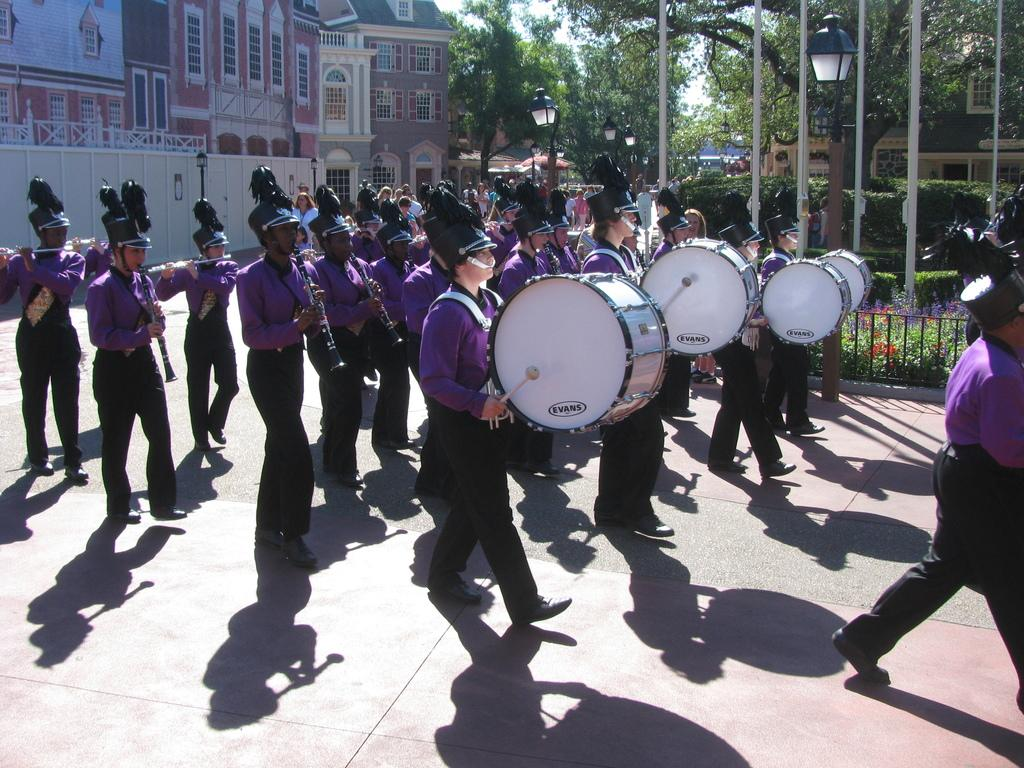What are the people in the image doing? The people in the image are holding musical instruments. What is the setting of the image? The people are walking on a road, and there are buildings and trees visible in the image. What type of crown is the representative wearing in the image? There is no representative or crown present in the image. The people in the image are holding musical instruments and walking on a road. 